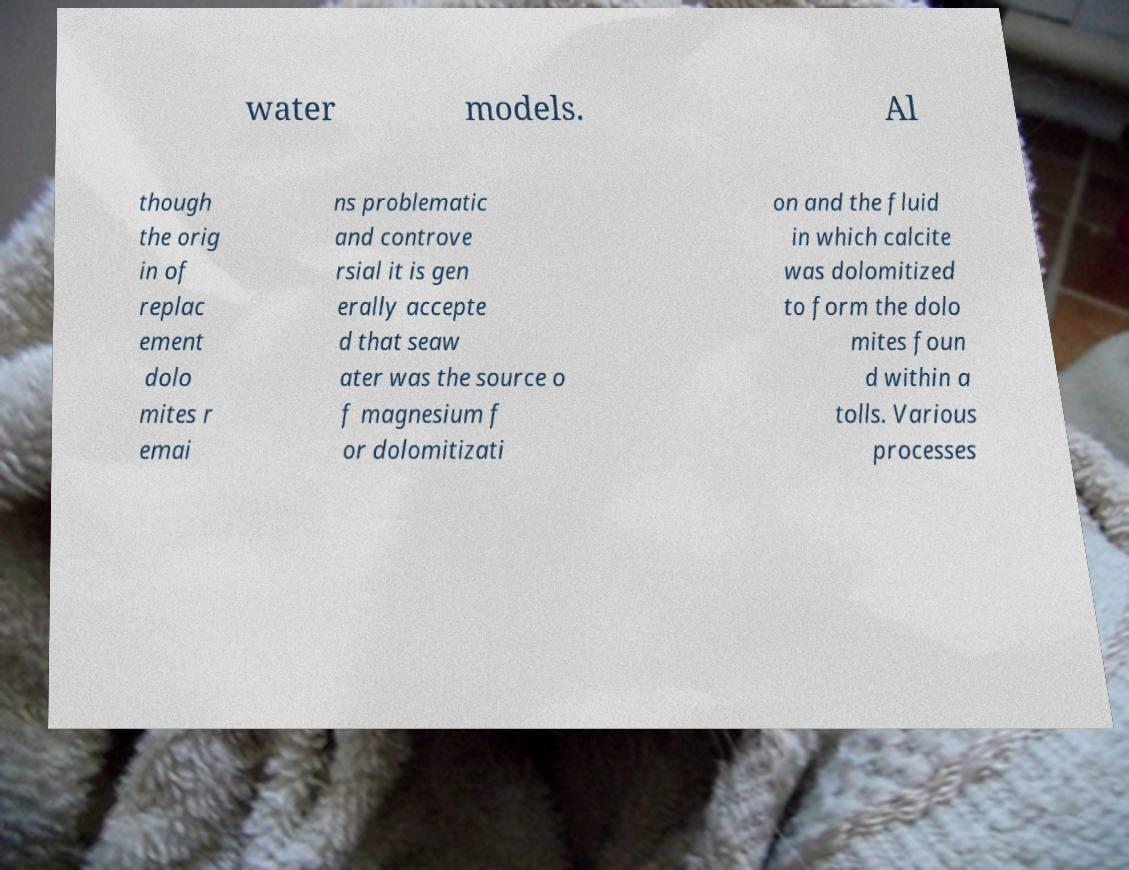Please read and relay the text visible in this image. What does it say? water models. Al though the orig in of replac ement dolo mites r emai ns problematic and controve rsial it is gen erally accepte d that seaw ater was the source o f magnesium f or dolomitizati on and the fluid in which calcite was dolomitized to form the dolo mites foun d within a tolls. Various processes 